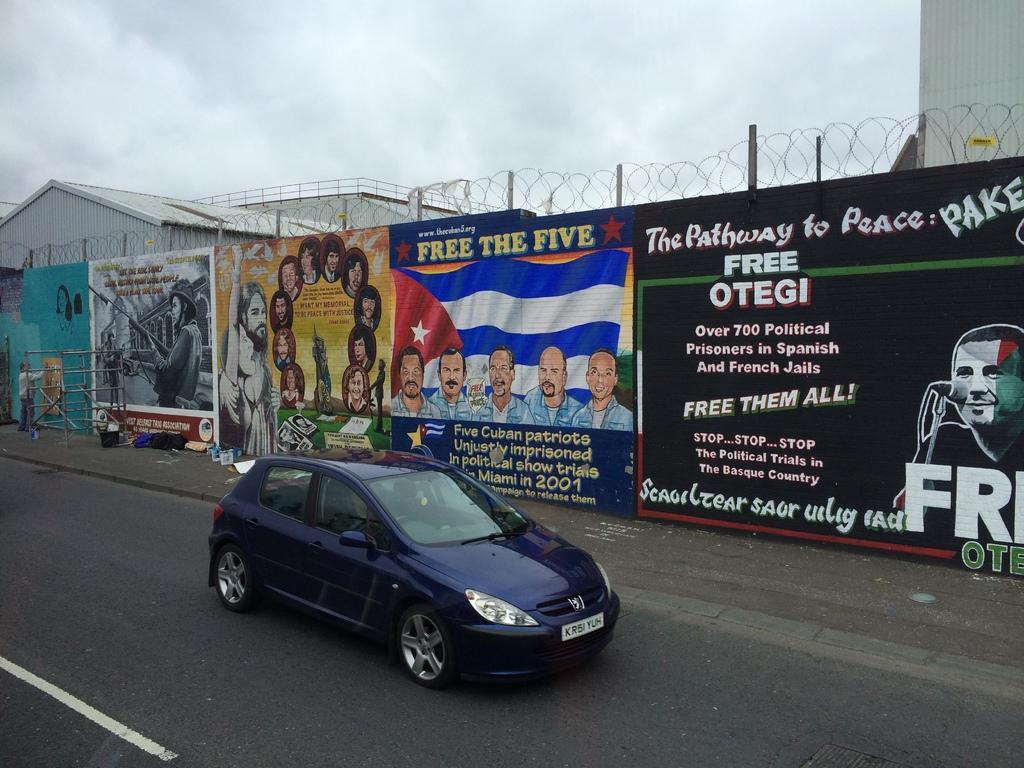Can you describe this image briefly? Here in this picture we can see a car present on the road and beside that on the wall we can see banners present and at the top we can see fencing present and beside that we can see a shed present and we can also see a person standing in front of the shed and we can see the sky is cloudy. 